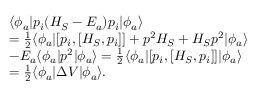<formula> <loc_0><loc_0><loc_500><loc_500>\begin{array} { r l } & { \langle \phi _ { a } | p _ { i } ( H _ { S } - E _ { a } ) p _ { i } | \phi _ { a } \rangle } \\ & { = \frac { 1 } { 2 } \langle \phi _ { a } | [ p _ { i } , [ H _ { S } , p _ { i } ] ] + p ^ { 2 } H _ { S } + H _ { S } p ^ { 2 } | \phi _ { a } \rangle } \\ & { - E _ { a } \langle \phi _ { a } | p ^ { 2 } | \phi _ { a } \rangle = \frac { 1 } { 2 } \langle \phi _ { a } | [ p _ { i } , [ H _ { S } , p _ { i } ] ] | \phi _ { a } \rangle } \\ & { = \frac { 1 } { 2 } \langle \phi _ { a } | \Delta V | \phi _ { a } \rangle . } \end{array}</formula> 